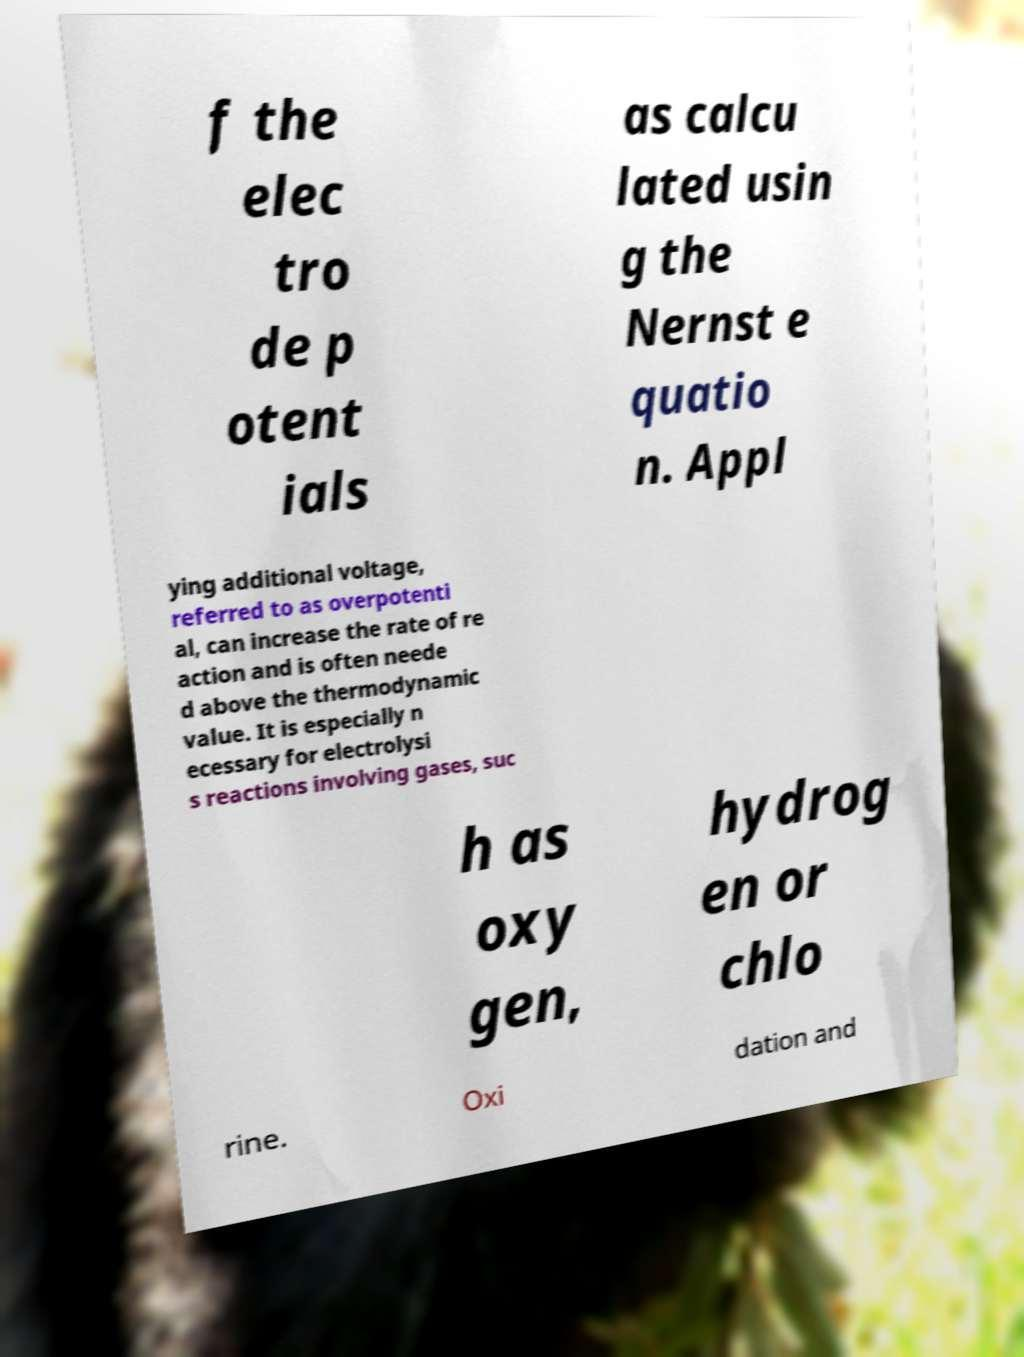Please read and relay the text visible in this image. What does it say? f the elec tro de p otent ials as calcu lated usin g the Nernst e quatio n. Appl ying additional voltage, referred to as overpotenti al, can increase the rate of re action and is often neede d above the thermodynamic value. It is especially n ecessary for electrolysi s reactions involving gases, suc h as oxy gen, hydrog en or chlo rine. Oxi dation and 